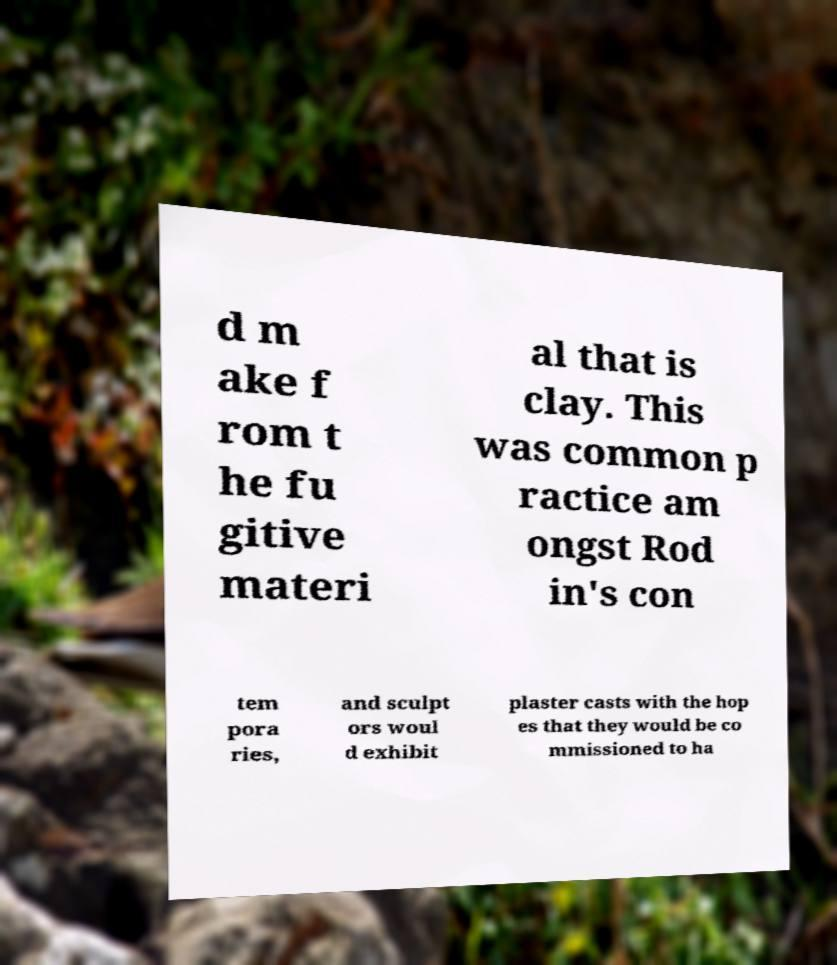Please identify and transcribe the text found in this image. d m ake f rom t he fu gitive materi al that is clay. This was common p ractice am ongst Rod in's con tem pora ries, and sculpt ors woul d exhibit plaster casts with the hop es that they would be co mmissioned to ha 